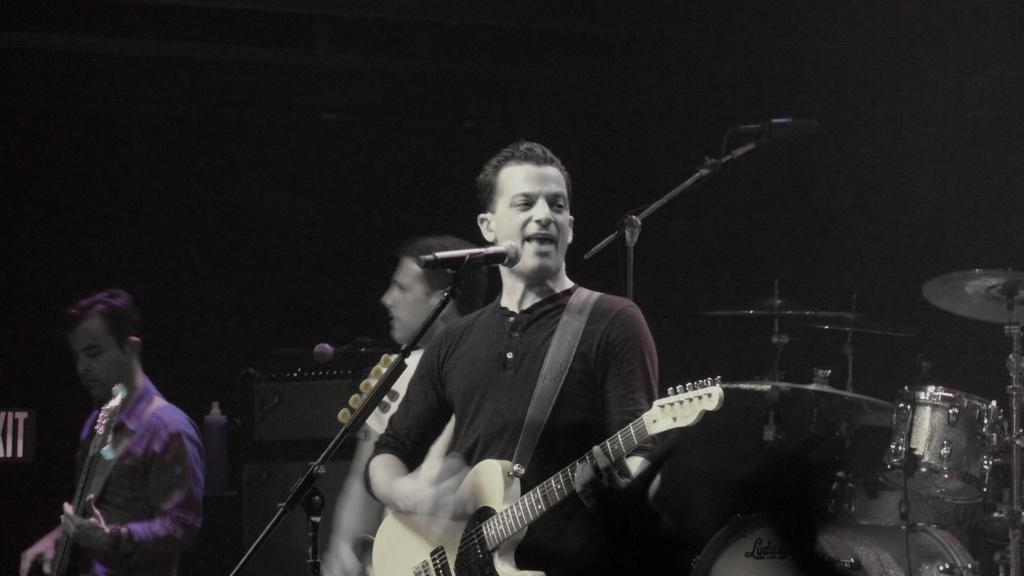What are the persons in the image doing? The persons in the image are standing and playing musical instruments. Is there any vocal component to their performance? Yes, one person is singing. What equipment is present to amplify their voices? There are microphones with stands. What other musical instruments can be seen in the image? There is at least one musical instrument visible behind the persons. What is the amount of yarn used in the image? There is no yarn present in the image. What authority figure is overseeing the performance in the image? There is no authority figure mentioned or depicted in the image. 